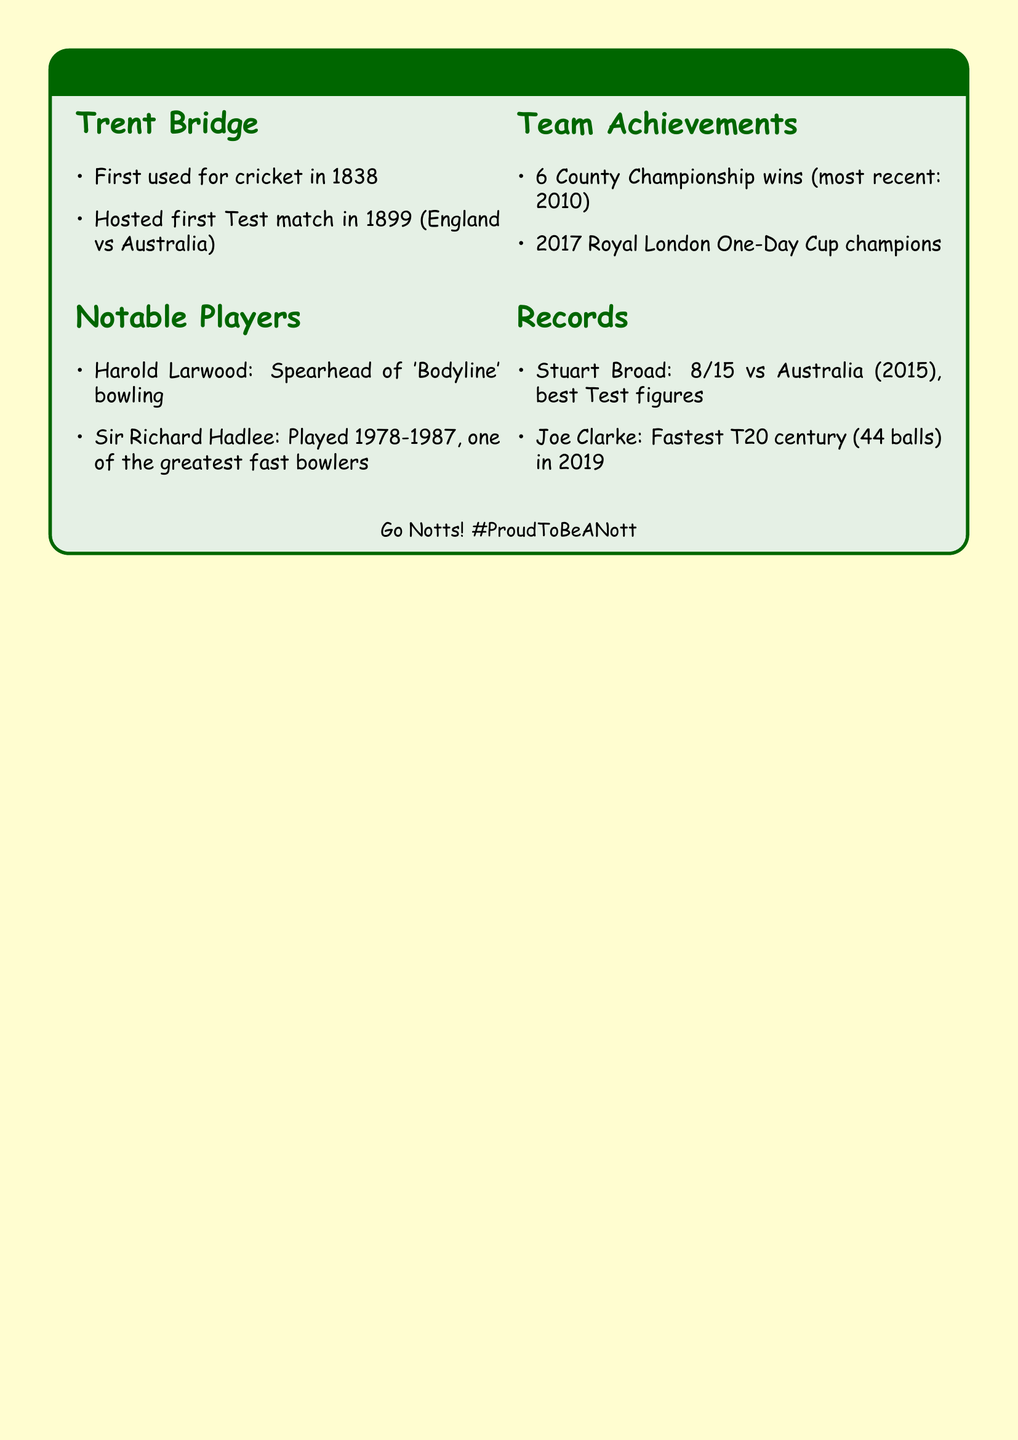What year was Trent Bridge first used for cricket? The year Trent Bridge was first used for cricket is specifically mentioned in the document.
Answer: 1838 Who is the spearhead of England's 'Bodyline' bowling strategy? The document identifies Harold Larwood as the spearhead of the 'Bodyline' bowling strategy.
Answer: Harold Larwood How many County Championship titles has Nottinghamshire won? The document states the number of County Championship wins by Nottinghamshire.
Answer: Six What is the fastest T20 century score for Nottinghamshire? The document provides the information about the fastest T20 century by Joe Clarke, specifying how quickly he achieved it.
Answer: 44 balls In what year did Nottinghamshire win the Royal London One-Day Cup? The document mentions the year Nottinghamshire won the Royal London One-Day Cup.
Answer: 2017 Who played for Nottinghamshire from 1978 to 1987? The document lists this notable player and their tenure with the team.
Answer: Sir Richard Hadlee What were Stuart Broad's figures against Australia in 2015? The document records the specific figures that highlight Stuart Broad's achievement.
Answer: 8/15 What significant event at Trent Bridge occurred in 1899? The document indicates an important cricket event that took place at Trent Bridge in this year.
Answer: First Test match 